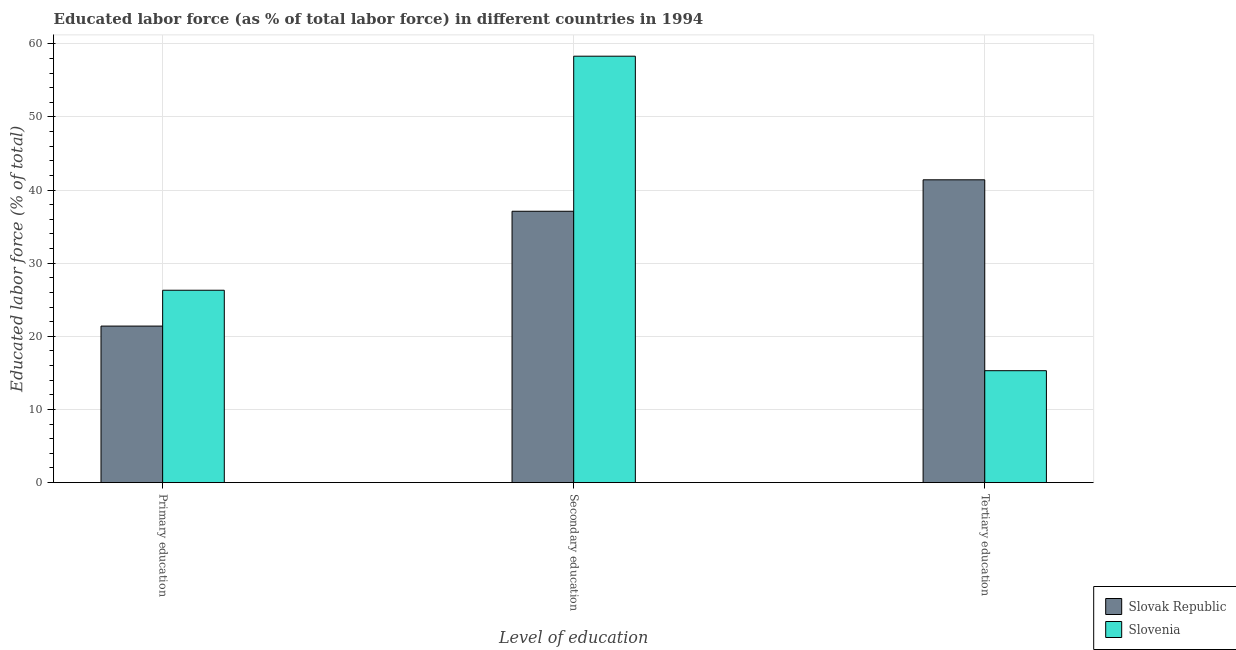How many different coloured bars are there?
Keep it short and to the point. 2. How many bars are there on the 2nd tick from the right?
Provide a short and direct response. 2. What is the label of the 1st group of bars from the left?
Provide a succinct answer. Primary education. What is the percentage of labor force who received tertiary education in Slovak Republic?
Give a very brief answer. 41.4. Across all countries, what is the maximum percentage of labor force who received secondary education?
Your answer should be compact. 58.3. Across all countries, what is the minimum percentage of labor force who received primary education?
Provide a succinct answer. 21.4. In which country was the percentage of labor force who received primary education maximum?
Offer a very short reply. Slovenia. In which country was the percentage of labor force who received primary education minimum?
Your response must be concise. Slovak Republic. What is the total percentage of labor force who received primary education in the graph?
Make the answer very short. 47.7. What is the difference between the percentage of labor force who received secondary education in Slovenia and that in Slovak Republic?
Give a very brief answer. 21.2. What is the difference between the percentage of labor force who received tertiary education in Slovenia and the percentage of labor force who received secondary education in Slovak Republic?
Provide a short and direct response. -21.8. What is the average percentage of labor force who received primary education per country?
Your answer should be very brief. 23.85. What is the difference between the percentage of labor force who received tertiary education and percentage of labor force who received primary education in Slovak Republic?
Make the answer very short. 20. In how many countries, is the percentage of labor force who received primary education greater than 22 %?
Offer a very short reply. 1. What is the ratio of the percentage of labor force who received primary education in Slovenia to that in Slovak Republic?
Give a very brief answer. 1.23. Is the percentage of labor force who received secondary education in Slovenia less than that in Slovak Republic?
Give a very brief answer. No. What is the difference between the highest and the second highest percentage of labor force who received primary education?
Keep it short and to the point. 4.9. What is the difference between the highest and the lowest percentage of labor force who received secondary education?
Your answer should be very brief. 21.2. In how many countries, is the percentage of labor force who received secondary education greater than the average percentage of labor force who received secondary education taken over all countries?
Provide a succinct answer. 1. Is the sum of the percentage of labor force who received primary education in Slovenia and Slovak Republic greater than the maximum percentage of labor force who received secondary education across all countries?
Your answer should be compact. No. What does the 2nd bar from the left in Tertiary education represents?
Give a very brief answer. Slovenia. What does the 1st bar from the right in Tertiary education represents?
Provide a short and direct response. Slovenia. Is it the case that in every country, the sum of the percentage of labor force who received primary education and percentage of labor force who received secondary education is greater than the percentage of labor force who received tertiary education?
Offer a very short reply. Yes. How many bars are there?
Offer a terse response. 6. Are all the bars in the graph horizontal?
Make the answer very short. No. What is the difference between two consecutive major ticks on the Y-axis?
Give a very brief answer. 10. Are the values on the major ticks of Y-axis written in scientific E-notation?
Your response must be concise. No. Does the graph contain grids?
Ensure brevity in your answer.  Yes. How many legend labels are there?
Ensure brevity in your answer.  2. What is the title of the graph?
Offer a terse response. Educated labor force (as % of total labor force) in different countries in 1994. Does "Qatar" appear as one of the legend labels in the graph?
Your response must be concise. No. What is the label or title of the X-axis?
Make the answer very short. Level of education. What is the label or title of the Y-axis?
Give a very brief answer. Educated labor force (% of total). What is the Educated labor force (% of total) in Slovak Republic in Primary education?
Offer a very short reply. 21.4. What is the Educated labor force (% of total) of Slovenia in Primary education?
Provide a short and direct response. 26.3. What is the Educated labor force (% of total) in Slovak Republic in Secondary education?
Your answer should be very brief. 37.1. What is the Educated labor force (% of total) of Slovenia in Secondary education?
Offer a terse response. 58.3. What is the Educated labor force (% of total) in Slovak Republic in Tertiary education?
Make the answer very short. 41.4. What is the Educated labor force (% of total) of Slovenia in Tertiary education?
Keep it short and to the point. 15.3. Across all Level of education, what is the maximum Educated labor force (% of total) in Slovak Republic?
Your response must be concise. 41.4. Across all Level of education, what is the maximum Educated labor force (% of total) of Slovenia?
Your answer should be compact. 58.3. Across all Level of education, what is the minimum Educated labor force (% of total) in Slovak Republic?
Make the answer very short. 21.4. Across all Level of education, what is the minimum Educated labor force (% of total) of Slovenia?
Make the answer very short. 15.3. What is the total Educated labor force (% of total) in Slovak Republic in the graph?
Your answer should be compact. 99.9. What is the total Educated labor force (% of total) of Slovenia in the graph?
Keep it short and to the point. 99.9. What is the difference between the Educated labor force (% of total) in Slovak Republic in Primary education and that in Secondary education?
Give a very brief answer. -15.7. What is the difference between the Educated labor force (% of total) in Slovenia in Primary education and that in Secondary education?
Give a very brief answer. -32. What is the difference between the Educated labor force (% of total) in Slovak Republic in Primary education and that in Tertiary education?
Give a very brief answer. -20. What is the difference between the Educated labor force (% of total) in Slovenia in Secondary education and that in Tertiary education?
Your response must be concise. 43. What is the difference between the Educated labor force (% of total) of Slovak Republic in Primary education and the Educated labor force (% of total) of Slovenia in Secondary education?
Give a very brief answer. -36.9. What is the difference between the Educated labor force (% of total) of Slovak Republic in Secondary education and the Educated labor force (% of total) of Slovenia in Tertiary education?
Provide a short and direct response. 21.8. What is the average Educated labor force (% of total) in Slovak Republic per Level of education?
Offer a terse response. 33.3. What is the average Educated labor force (% of total) in Slovenia per Level of education?
Keep it short and to the point. 33.3. What is the difference between the Educated labor force (% of total) of Slovak Republic and Educated labor force (% of total) of Slovenia in Primary education?
Your answer should be compact. -4.9. What is the difference between the Educated labor force (% of total) of Slovak Republic and Educated labor force (% of total) of Slovenia in Secondary education?
Give a very brief answer. -21.2. What is the difference between the Educated labor force (% of total) in Slovak Republic and Educated labor force (% of total) in Slovenia in Tertiary education?
Keep it short and to the point. 26.1. What is the ratio of the Educated labor force (% of total) of Slovak Republic in Primary education to that in Secondary education?
Offer a terse response. 0.58. What is the ratio of the Educated labor force (% of total) in Slovenia in Primary education to that in Secondary education?
Your answer should be very brief. 0.45. What is the ratio of the Educated labor force (% of total) in Slovak Republic in Primary education to that in Tertiary education?
Offer a very short reply. 0.52. What is the ratio of the Educated labor force (% of total) in Slovenia in Primary education to that in Tertiary education?
Provide a short and direct response. 1.72. What is the ratio of the Educated labor force (% of total) of Slovak Republic in Secondary education to that in Tertiary education?
Your response must be concise. 0.9. What is the ratio of the Educated labor force (% of total) in Slovenia in Secondary education to that in Tertiary education?
Make the answer very short. 3.81. What is the difference between the highest and the second highest Educated labor force (% of total) in Slovak Republic?
Your response must be concise. 4.3. 